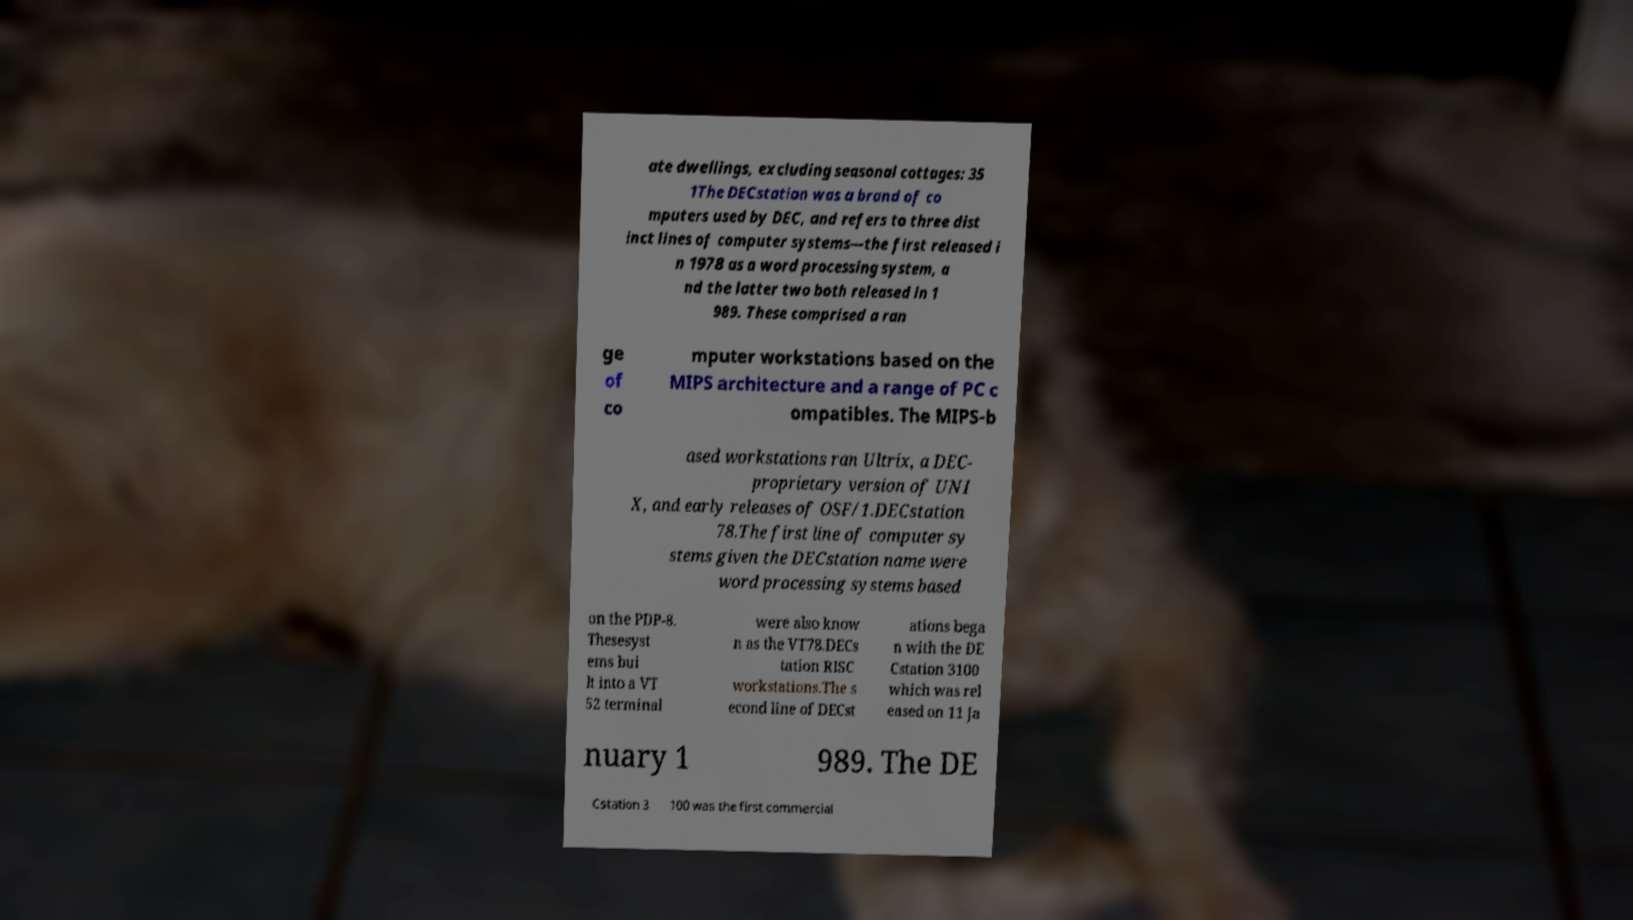I need the written content from this picture converted into text. Can you do that? ate dwellings, excluding seasonal cottages: 35 1The DECstation was a brand of co mputers used by DEC, and refers to three dist inct lines of computer systems—the first released i n 1978 as a word processing system, a nd the latter two both released in 1 989. These comprised a ran ge of co mputer workstations based on the MIPS architecture and a range of PC c ompatibles. The MIPS-b ased workstations ran Ultrix, a DEC- proprietary version of UNI X, and early releases of OSF/1.DECstation 78.The first line of computer sy stems given the DECstation name were word processing systems based on the PDP-8. Thesesyst ems bui lt into a VT 52 terminal were also know n as the VT78.DECs tation RISC workstations.The s econd line of DECst ations bega n with the DE Cstation 3100 which was rel eased on 11 Ja nuary 1 989. The DE Cstation 3 100 was the first commercial 